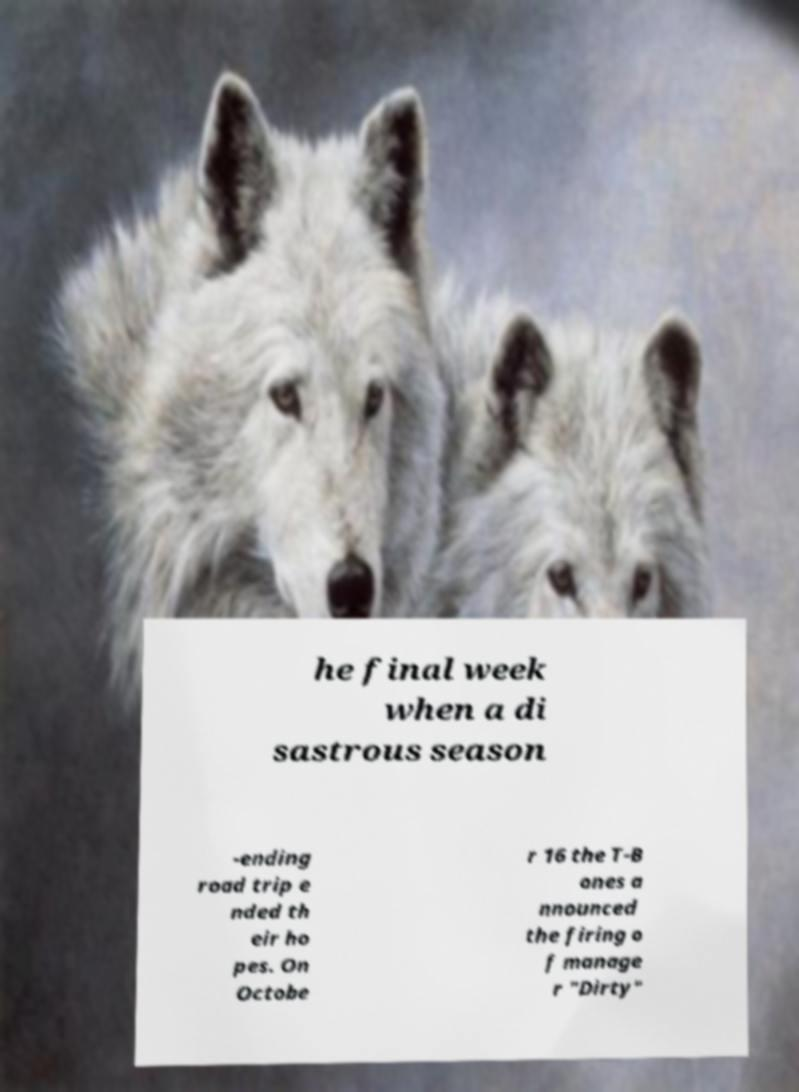What messages or text are displayed in this image? I need them in a readable, typed format. he final week when a di sastrous season -ending road trip e nded th eir ho pes. On Octobe r 16 the T-B ones a nnounced the firing o f manage r "Dirty" 